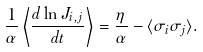<formula> <loc_0><loc_0><loc_500><loc_500>\frac { 1 } { \alpha } \left \langle \frac { d \ln J _ { i , j } } { d t } \right \rangle = \frac { \eta } { \alpha } - \langle \sigma _ { i } \sigma _ { j } \rangle .</formula> 